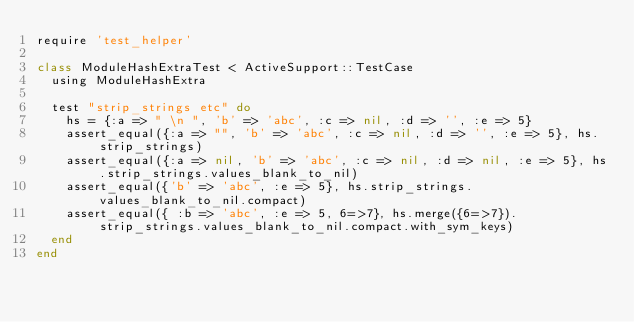<code> <loc_0><loc_0><loc_500><loc_500><_Ruby_>require 'test_helper'

class ModuleHashExtraTest < ActiveSupport::TestCase
  using ModuleHashExtra
  
  test "strip_strings etc" do
    hs = {:a => " \n ", 'b' => 'abc', :c => nil, :d => '', :e => 5}
    assert_equal({:a => "", 'b' => 'abc', :c => nil, :d => '', :e => 5}, hs.strip_strings)
    assert_equal({:a => nil, 'b' => 'abc', :c => nil, :d => nil, :e => 5}, hs.strip_strings.values_blank_to_nil)
    assert_equal({'b' => 'abc', :e => 5}, hs.strip_strings.values_blank_to_nil.compact)
    assert_equal({ :b => 'abc', :e => 5, 6=>7}, hs.merge({6=>7}).strip_strings.values_blank_to_nil.compact.with_sym_keys)
  end
end
</code> 